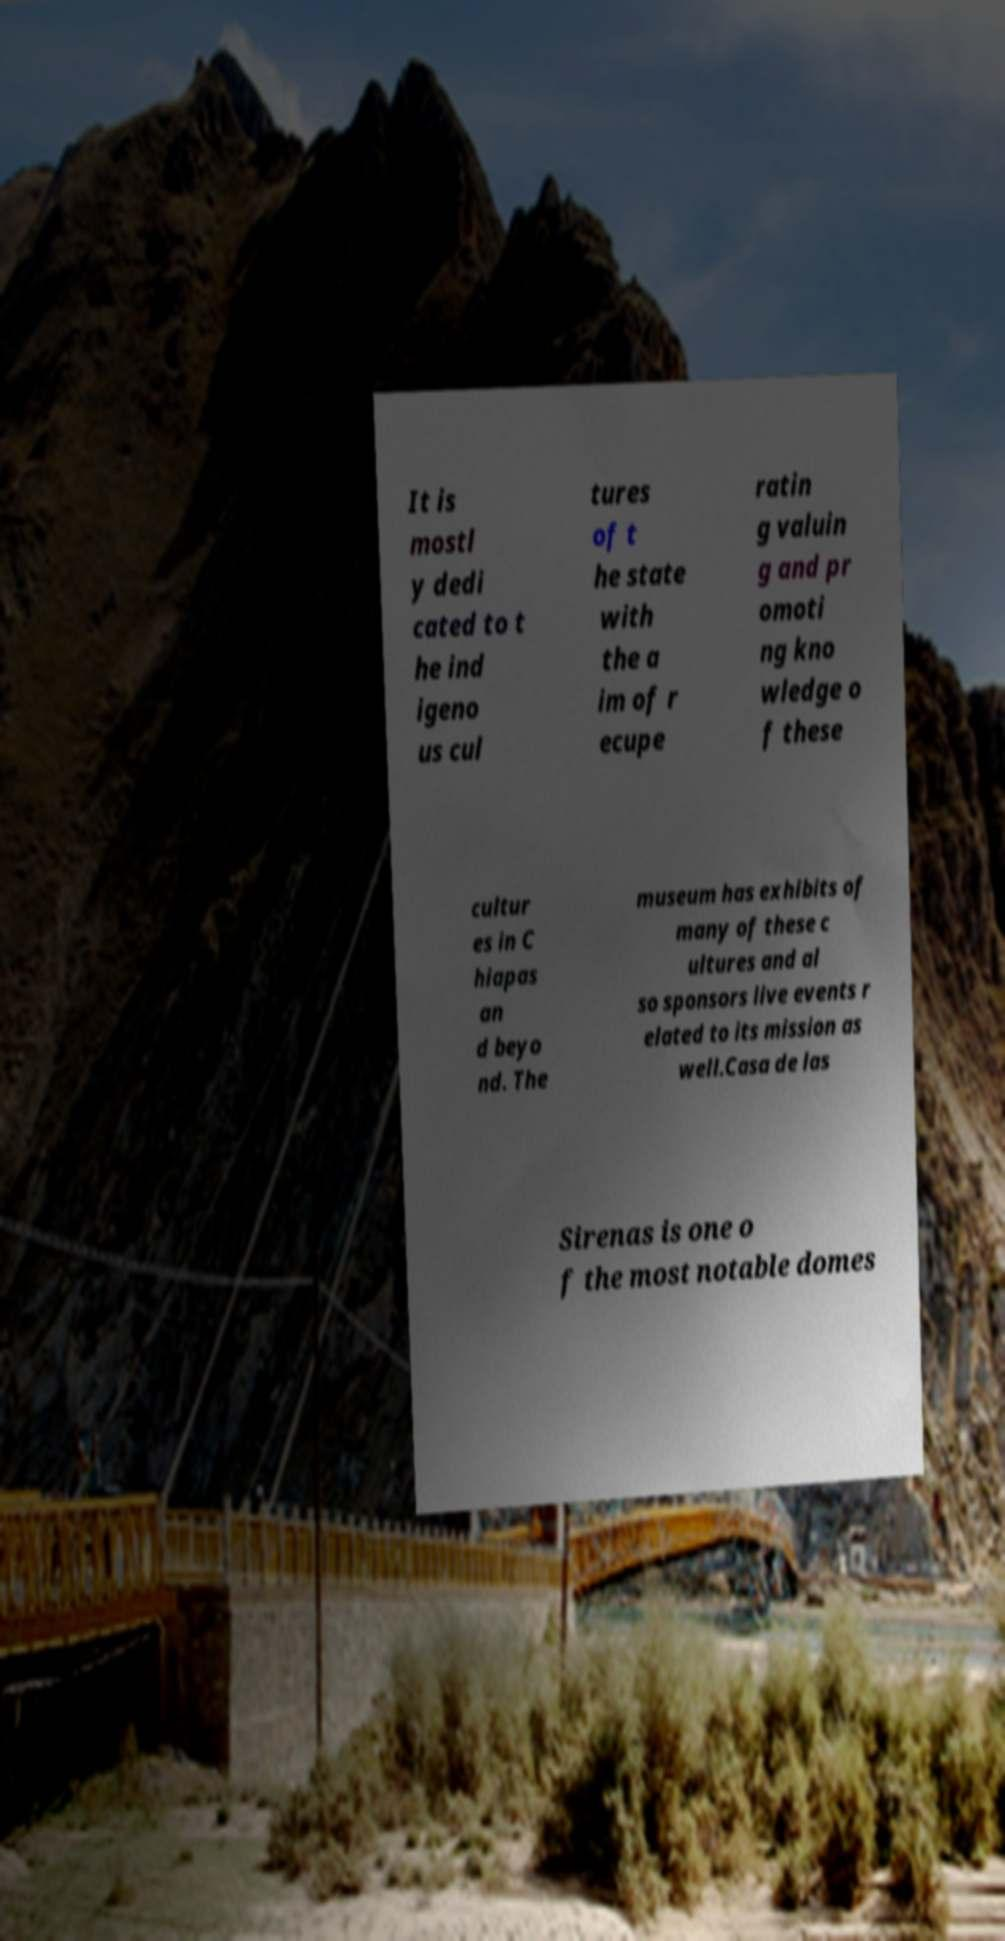Can you accurately transcribe the text from the provided image for me? It is mostl y dedi cated to t he ind igeno us cul tures of t he state with the a im of r ecupe ratin g valuin g and pr omoti ng kno wledge o f these cultur es in C hiapas an d beyo nd. The museum has exhibits of many of these c ultures and al so sponsors live events r elated to its mission as well.Casa de las Sirenas is one o f the most notable domes 